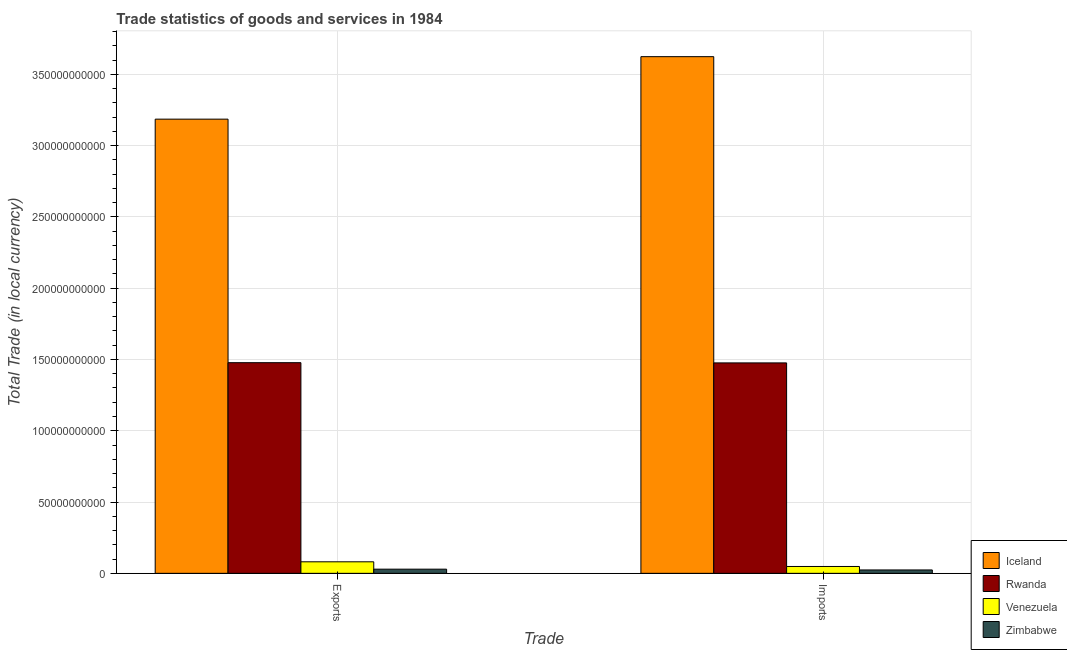How many different coloured bars are there?
Offer a terse response. 4. How many groups of bars are there?
Offer a terse response. 2. What is the label of the 2nd group of bars from the left?
Give a very brief answer. Imports. What is the imports of goods and services in Rwanda?
Ensure brevity in your answer.  1.48e+11. Across all countries, what is the maximum imports of goods and services?
Offer a very short reply. 3.62e+11. Across all countries, what is the minimum imports of goods and services?
Ensure brevity in your answer.  2.37e+09. In which country was the imports of goods and services maximum?
Provide a succinct answer. Iceland. In which country was the export of goods and services minimum?
Offer a very short reply. Zimbabwe. What is the total export of goods and services in the graph?
Provide a short and direct response. 4.77e+11. What is the difference between the imports of goods and services in Iceland and that in Rwanda?
Provide a short and direct response. 2.15e+11. What is the difference between the export of goods and services in Zimbabwe and the imports of goods and services in Venezuela?
Provide a short and direct response. -1.89e+09. What is the average export of goods and services per country?
Provide a succinct answer. 1.19e+11. What is the difference between the export of goods and services and imports of goods and services in Rwanda?
Provide a succinct answer. 1.54e+08. In how many countries, is the imports of goods and services greater than 40000000000 LCU?
Your response must be concise. 2. What is the ratio of the export of goods and services in Iceland to that in Venezuela?
Make the answer very short. 39.42. In how many countries, is the imports of goods and services greater than the average imports of goods and services taken over all countries?
Your answer should be compact. 2. What does the 3rd bar from the left in Imports represents?
Offer a very short reply. Venezuela. What does the 1st bar from the right in Imports represents?
Your answer should be compact. Zimbabwe. What is the difference between two consecutive major ticks on the Y-axis?
Provide a succinct answer. 5.00e+1. What is the title of the graph?
Keep it short and to the point. Trade statistics of goods and services in 1984. What is the label or title of the X-axis?
Make the answer very short. Trade. What is the label or title of the Y-axis?
Ensure brevity in your answer.  Total Trade (in local currency). What is the Total Trade (in local currency) in Iceland in Exports?
Make the answer very short. 3.19e+11. What is the Total Trade (in local currency) in Rwanda in Exports?
Ensure brevity in your answer.  1.48e+11. What is the Total Trade (in local currency) of Venezuela in Exports?
Ensure brevity in your answer.  8.08e+09. What is the Total Trade (in local currency) of Zimbabwe in Exports?
Provide a short and direct response. 2.92e+09. What is the Total Trade (in local currency) of Iceland in Imports?
Your answer should be compact. 3.62e+11. What is the Total Trade (in local currency) in Rwanda in Imports?
Provide a succinct answer. 1.48e+11. What is the Total Trade (in local currency) of Venezuela in Imports?
Provide a short and direct response. 4.81e+09. What is the Total Trade (in local currency) of Zimbabwe in Imports?
Ensure brevity in your answer.  2.37e+09. Across all Trade, what is the maximum Total Trade (in local currency) of Iceland?
Provide a short and direct response. 3.62e+11. Across all Trade, what is the maximum Total Trade (in local currency) in Rwanda?
Offer a terse response. 1.48e+11. Across all Trade, what is the maximum Total Trade (in local currency) of Venezuela?
Provide a succinct answer. 8.08e+09. Across all Trade, what is the maximum Total Trade (in local currency) in Zimbabwe?
Your answer should be very brief. 2.92e+09. Across all Trade, what is the minimum Total Trade (in local currency) in Iceland?
Give a very brief answer. 3.19e+11. Across all Trade, what is the minimum Total Trade (in local currency) in Rwanda?
Ensure brevity in your answer.  1.48e+11. Across all Trade, what is the minimum Total Trade (in local currency) of Venezuela?
Provide a short and direct response. 4.81e+09. Across all Trade, what is the minimum Total Trade (in local currency) in Zimbabwe?
Ensure brevity in your answer.  2.37e+09. What is the total Total Trade (in local currency) in Iceland in the graph?
Make the answer very short. 6.81e+11. What is the total Total Trade (in local currency) in Rwanda in the graph?
Your answer should be very brief. 2.95e+11. What is the total Total Trade (in local currency) in Venezuela in the graph?
Keep it short and to the point. 1.29e+1. What is the total Total Trade (in local currency) of Zimbabwe in the graph?
Your response must be concise. 5.29e+09. What is the difference between the Total Trade (in local currency) in Iceland in Exports and that in Imports?
Make the answer very short. -4.38e+1. What is the difference between the Total Trade (in local currency) of Rwanda in Exports and that in Imports?
Ensure brevity in your answer.  1.54e+08. What is the difference between the Total Trade (in local currency) of Venezuela in Exports and that in Imports?
Keep it short and to the point. 3.27e+09. What is the difference between the Total Trade (in local currency) of Zimbabwe in Exports and that in Imports?
Offer a very short reply. 5.46e+08. What is the difference between the Total Trade (in local currency) of Iceland in Exports and the Total Trade (in local currency) of Rwanda in Imports?
Your answer should be compact. 1.71e+11. What is the difference between the Total Trade (in local currency) in Iceland in Exports and the Total Trade (in local currency) in Venezuela in Imports?
Your answer should be very brief. 3.14e+11. What is the difference between the Total Trade (in local currency) in Iceland in Exports and the Total Trade (in local currency) in Zimbabwe in Imports?
Give a very brief answer. 3.16e+11. What is the difference between the Total Trade (in local currency) of Rwanda in Exports and the Total Trade (in local currency) of Venezuela in Imports?
Your response must be concise. 1.43e+11. What is the difference between the Total Trade (in local currency) in Rwanda in Exports and the Total Trade (in local currency) in Zimbabwe in Imports?
Your answer should be very brief. 1.45e+11. What is the difference between the Total Trade (in local currency) in Venezuela in Exports and the Total Trade (in local currency) in Zimbabwe in Imports?
Your answer should be compact. 5.71e+09. What is the average Total Trade (in local currency) in Iceland per Trade?
Offer a terse response. 3.40e+11. What is the average Total Trade (in local currency) of Rwanda per Trade?
Give a very brief answer. 1.48e+11. What is the average Total Trade (in local currency) in Venezuela per Trade?
Your answer should be very brief. 6.45e+09. What is the average Total Trade (in local currency) of Zimbabwe per Trade?
Your answer should be very brief. 2.65e+09. What is the difference between the Total Trade (in local currency) in Iceland and Total Trade (in local currency) in Rwanda in Exports?
Keep it short and to the point. 1.71e+11. What is the difference between the Total Trade (in local currency) of Iceland and Total Trade (in local currency) of Venezuela in Exports?
Give a very brief answer. 3.10e+11. What is the difference between the Total Trade (in local currency) in Iceland and Total Trade (in local currency) in Zimbabwe in Exports?
Your response must be concise. 3.16e+11. What is the difference between the Total Trade (in local currency) of Rwanda and Total Trade (in local currency) of Venezuela in Exports?
Give a very brief answer. 1.40e+11. What is the difference between the Total Trade (in local currency) in Rwanda and Total Trade (in local currency) in Zimbabwe in Exports?
Keep it short and to the point. 1.45e+11. What is the difference between the Total Trade (in local currency) of Venezuela and Total Trade (in local currency) of Zimbabwe in Exports?
Offer a terse response. 5.16e+09. What is the difference between the Total Trade (in local currency) in Iceland and Total Trade (in local currency) in Rwanda in Imports?
Provide a succinct answer. 2.15e+11. What is the difference between the Total Trade (in local currency) of Iceland and Total Trade (in local currency) of Venezuela in Imports?
Ensure brevity in your answer.  3.58e+11. What is the difference between the Total Trade (in local currency) of Iceland and Total Trade (in local currency) of Zimbabwe in Imports?
Give a very brief answer. 3.60e+11. What is the difference between the Total Trade (in local currency) of Rwanda and Total Trade (in local currency) of Venezuela in Imports?
Provide a succinct answer. 1.43e+11. What is the difference between the Total Trade (in local currency) in Rwanda and Total Trade (in local currency) in Zimbabwe in Imports?
Keep it short and to the point. 1.45e+11. What is the difference between the Total Trade (in local currency) of Venezuela and Total Trade (in local currency) of Zimbabwe in Imports?
Your answer should be very brief. 2.44e+09. What is the ratio of the Total Trade (in local currency) in Iceland in Exports to that in Imports?
Give a very brief answer. 0.88. What is the ratio of the Total Trade (in local currency) in Rwanda in Exports to that in Imports?
Your answer should be compact. 1. What is the ratio of the Total Trade (in local currency) of Venezuela in Exports to that in Imports?
Make the answer very short. 1.68. What is the ratio of the Total Trade (in local currency) of Zimbabwe in Exports to that in Imports?
Offer a very short reply. 1.23. What is the difference between the highest and the second highest Total Trade (in local currency) in Iceland?
Keep it short and to the point. 4.38e+1. What is the difference between the highest and the second highest Total Trade (in local currency) of Rwanda?
Provide a succinct answer. 1.54e+08. What is the difference between the highest and the second highest Total Trade (in local currency) of Venezuela?
Give a very brief answer. 3.27e+09. What is the difference between the highest and the second highest Total Trade (in local currency) in Zimbabwe?
Provide a short and direct response. 5.46e+08. What is the difference between the highest and the lowest Total Trade (in local currency) in Iceland?
Make the answer very short. 4.38e+1. What is the difference between the highest and the lowest Total Trade (in local currency) of Rwanda?
Ensure brevity in your answer.  1.54e+08. What is the difference between the highest and the lowest Total Trade (in local currency) of Venezuela?
Offer a very short reply. 3.27e+09. What is the difference between the highest and the lowest Total Trade (in local currency) of Zimbabwe?
Offer a very short reply. 5.46e+08. 